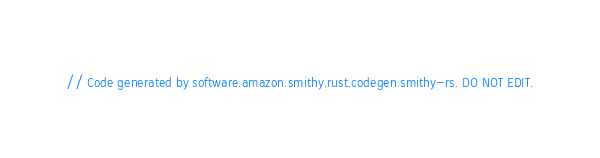<code> <loc_0><loc_0><loc_500><loc_500><_Rust_>// Code generated by software.amazon.smithy.rust.codegen.smithy-rs. DO NOT EDIT.</code> 